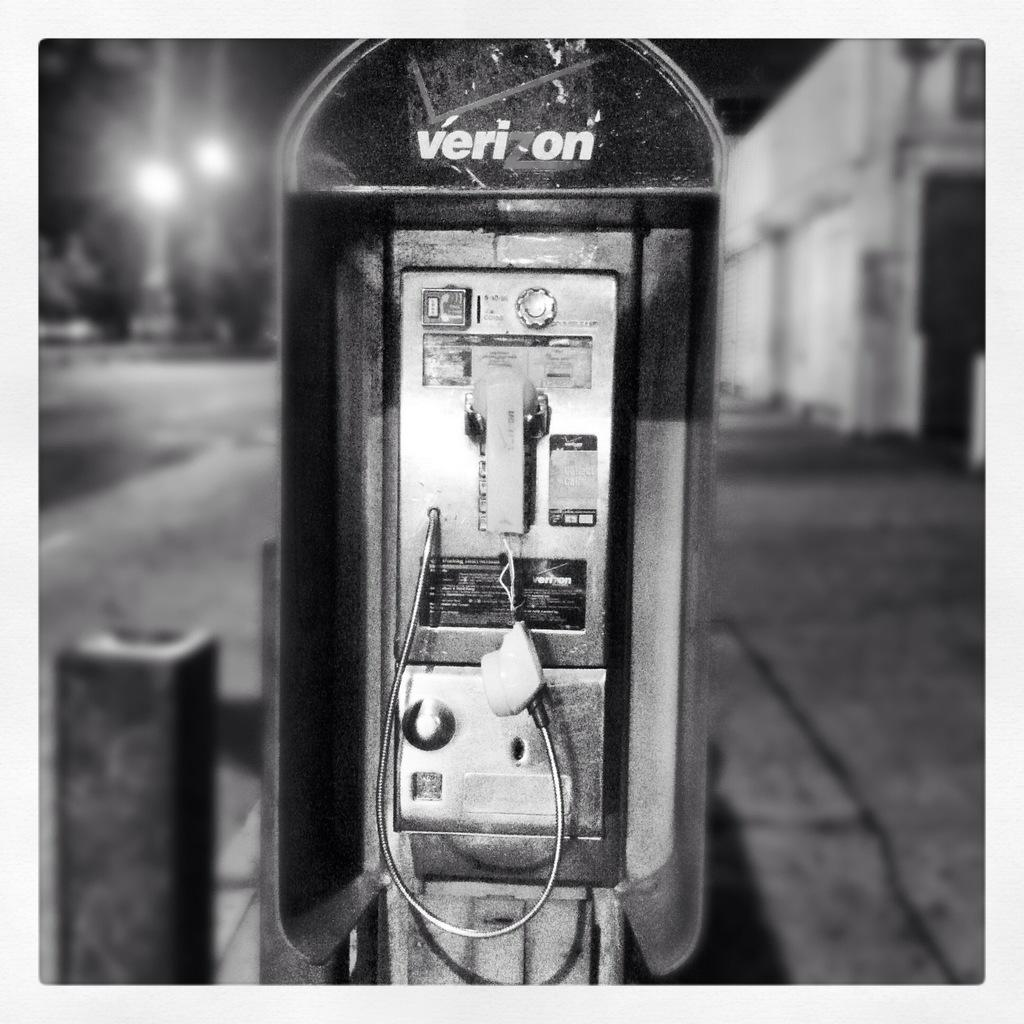<image>
Describe the image concisely. a phone that has the word Verizon on it 